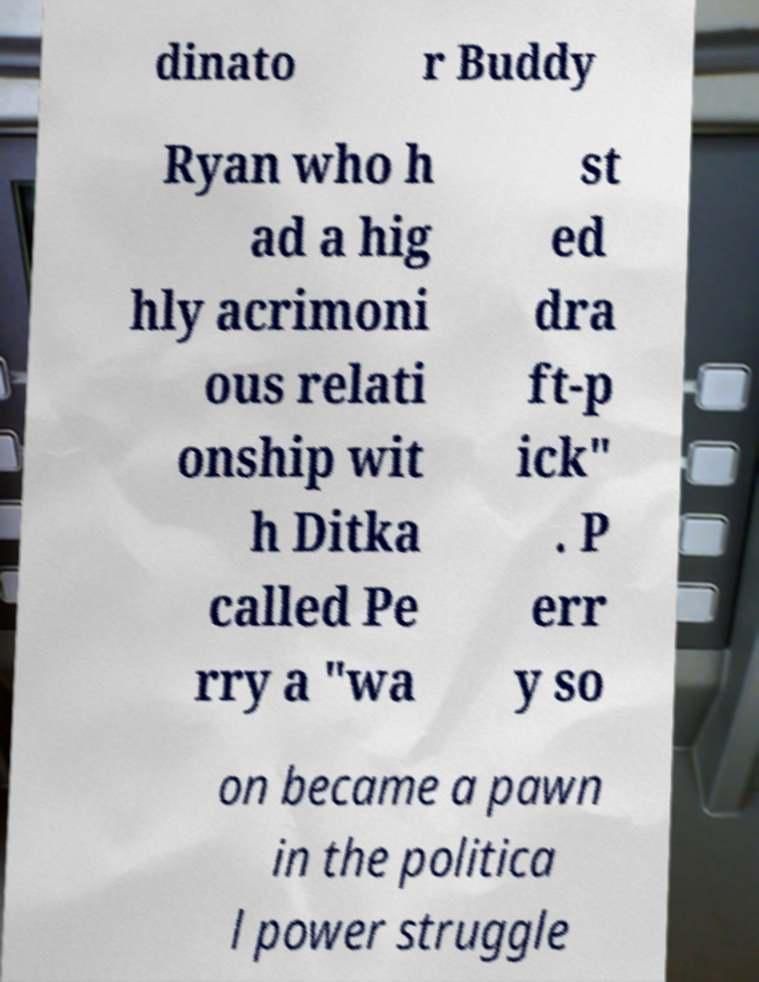Could you extract and type out the text from this image? dinato r Buddy Ryan who h ad a hig hly acrimoni ous relati onship wit h Ditka called Pe rry a "wa st ed dra ft-p ick" . P err y so on became a pawn in the politica l power struggle 